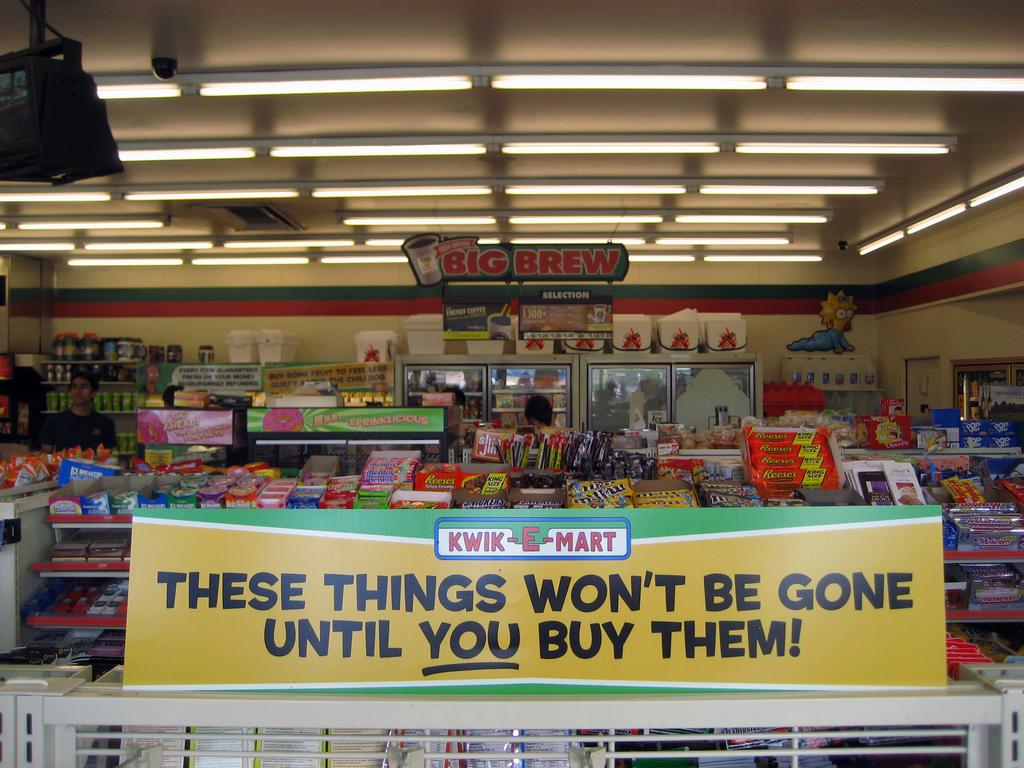Provide a one-sentence caption for the provided image. A Big Brew sign is hanging from the ceiling in a store. 